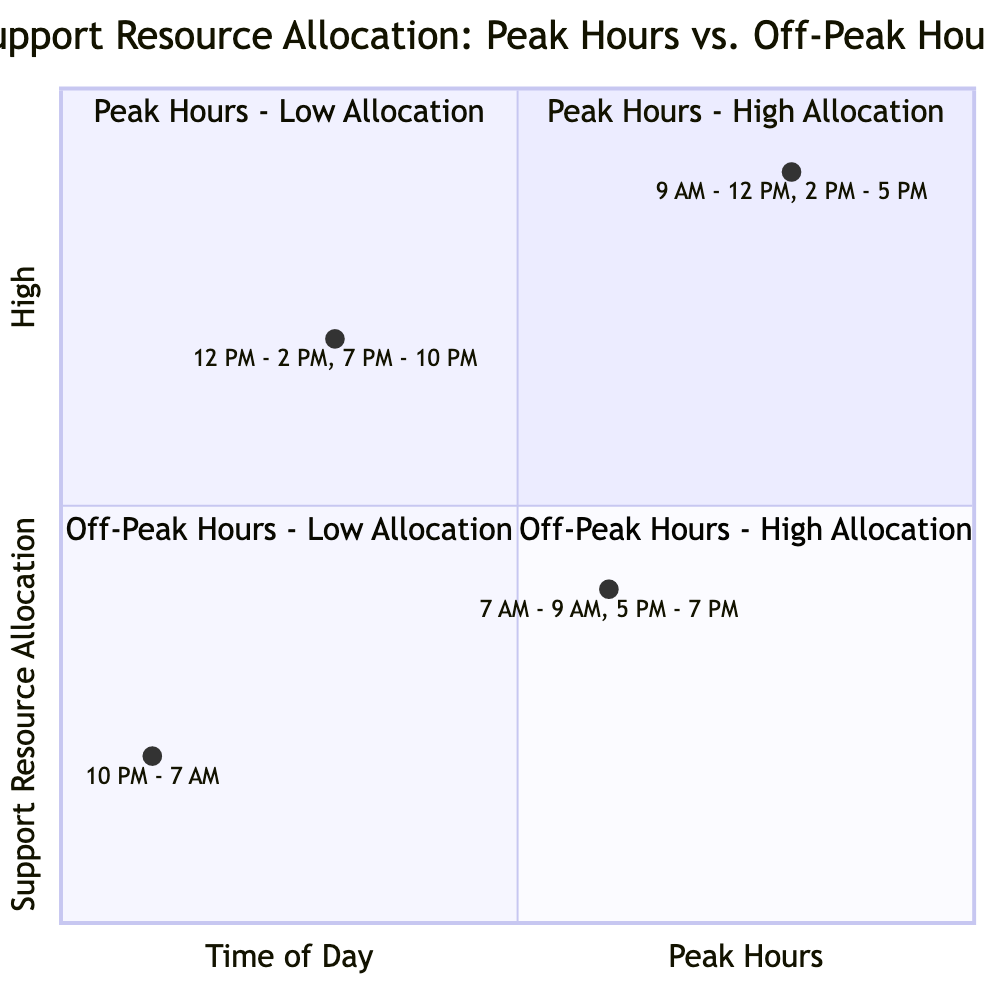What are the example times for Peak Hours - High Allocation? According to the diagram, the example times for the "Peak Hours - High Allocation" quadrant are specifically listed as "9 AM - 12 PM" and "2 PM - 5 PM."
Answer: 9 AM - 12 PM, 2 PM - 5 PM Which resources are allocated during Off-Peak Hours - Low Allocation? The resources specified in the "Off-Peak Hours - Low Allocation" quadrant include "AI Chatbots," "Email Handling with Extended Response Time," and "No Live Agent Support."
Answer: AI Chatbots, Email Handling with Extended Response Time, No Live Agent Support How many quadrants are there in the chart? The total number of quadrants presented in the diagram is explicitly four, as divided into the categories of Peak and Off-Peak Hours, alongside their respective resource allocations.
Answer: 4 What is the allocation level for Peak Hours - Low Allocation? In the quadrant labeled "Peak Hours - Low Allocation," the allocation level is characterized as being lower relative to high allocation, which indicates it is less than 0.5 on the vertical scale.
Answer: Low Which quadrant includes resources like Dedicate Phone Lines? The resources such as "Dedicated Phone Lines" are contained within the "Peak Hours - High Allocation" quadrant, as it denotes a high level of support resource allocation during peak hours.
Answer: Peak Hours - High Allocation What is the resource allocation for Off-Peak Hours - High Allocation? The "Off-Peak Hours - High Allocation" quadrant identifies a support resource allocation level that is higher than the off-peak low allocation, indicating effectiveness but lower compared to peak hours high allocation.
Answer: Moderate During which time frame does "Limited Live Chat Support" occur? The "Limited Live Chat Support" resource is listed as occurring during the "Peak Hours - Low Allocation," which includes the times "7 AM - 9 AM" and "5 PM - 7 PM."
Answer: 7 AM - 9 AM, 5 PM - 7 PM How do the resources compare between Peak Hours - High Allocation and Off-Peak Hours - High Allocation? The comparison between these quadrants indicates that "Peak Hours - High Allocation" has more extensive resources such as "24x7 Live Chat Support" and "Priority Email Handling," while "Off-Peak Hours - High Allocation" resources are more limited like "Email Handling with Moderate Response Time."
Answer: More extensive resources in peak hours What is the allocation for the time frame “10 PM - 7 AM”? The time frame "10 PM - 7 AM" is characterized under the "Off-Peak Hours - Low Allocation," representing one of the lowest allocation levels illustrated on the chart.
Answer: Low 